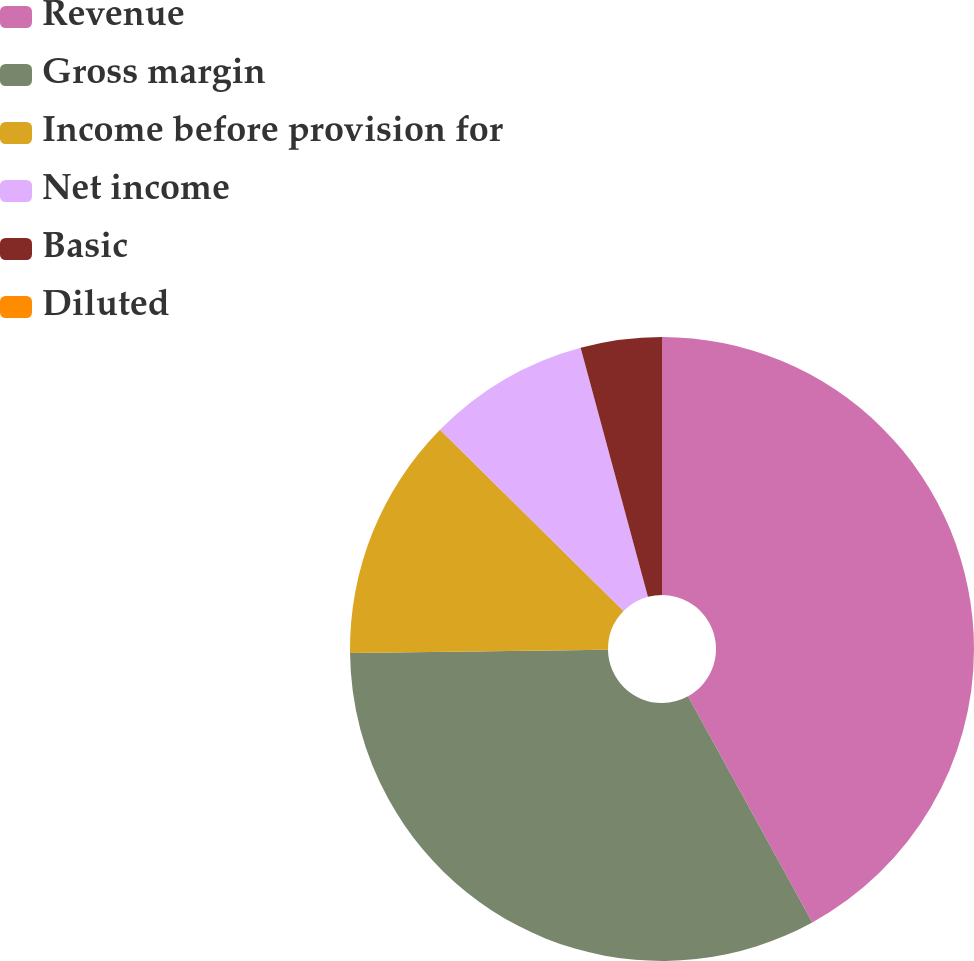<chart> <loc_0><loc_0><loc_500><loc_500><pie_chart><fcel>Revenue<fcel>Gross margin<fcel>Income before provision for<fcel>Net income<fcel>Basic<fcel>Diluted<nl><fcel>42.0%<fcel>32.8%<fcel>12.6%<fcel>8.4%<fcel>4.2%<fcel>0.0%<nl></chart> 